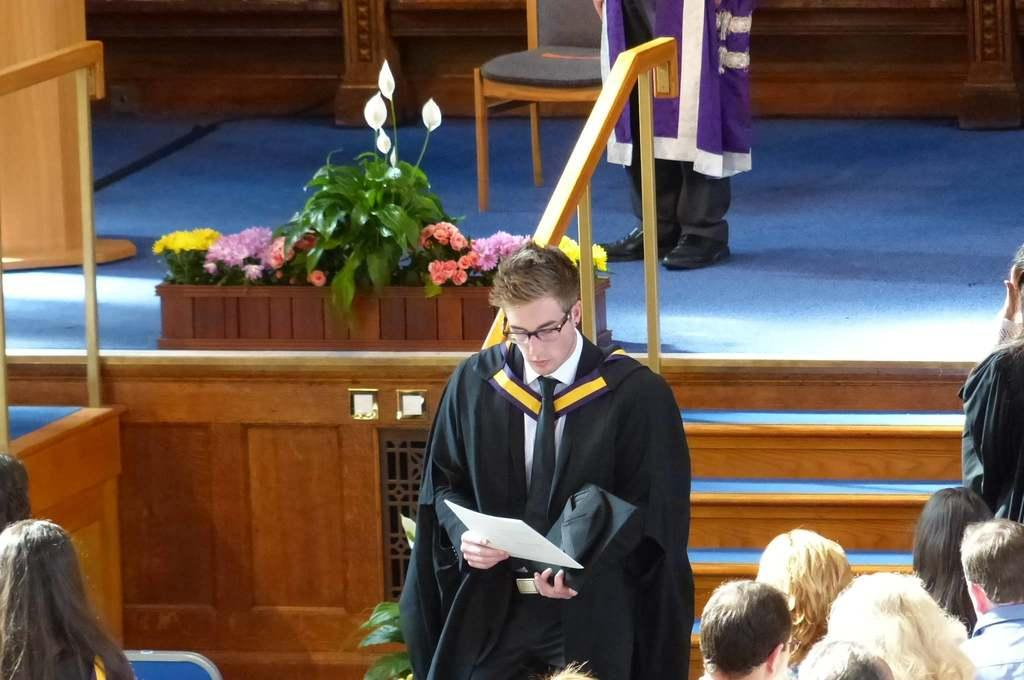What is the person holding in the image? The person is holding a paper. What is the person doing with the paper? The person is looking into the paper. What can be seen on the stage in the image? There is a person, a chair, and a plant on the stage. How many people are on the stage? There is only one person on the stage. Are there any people visible on the sides of the image? Yes, there are people on the left side and the right side of the image. What is the plot of the play being performed on the stage? There is no play being performed on the stage in the image, so there is no plot to describe. How many stars are visible in the image? There are no stars visible in the image; it is an indoor scene with a stage and people. 